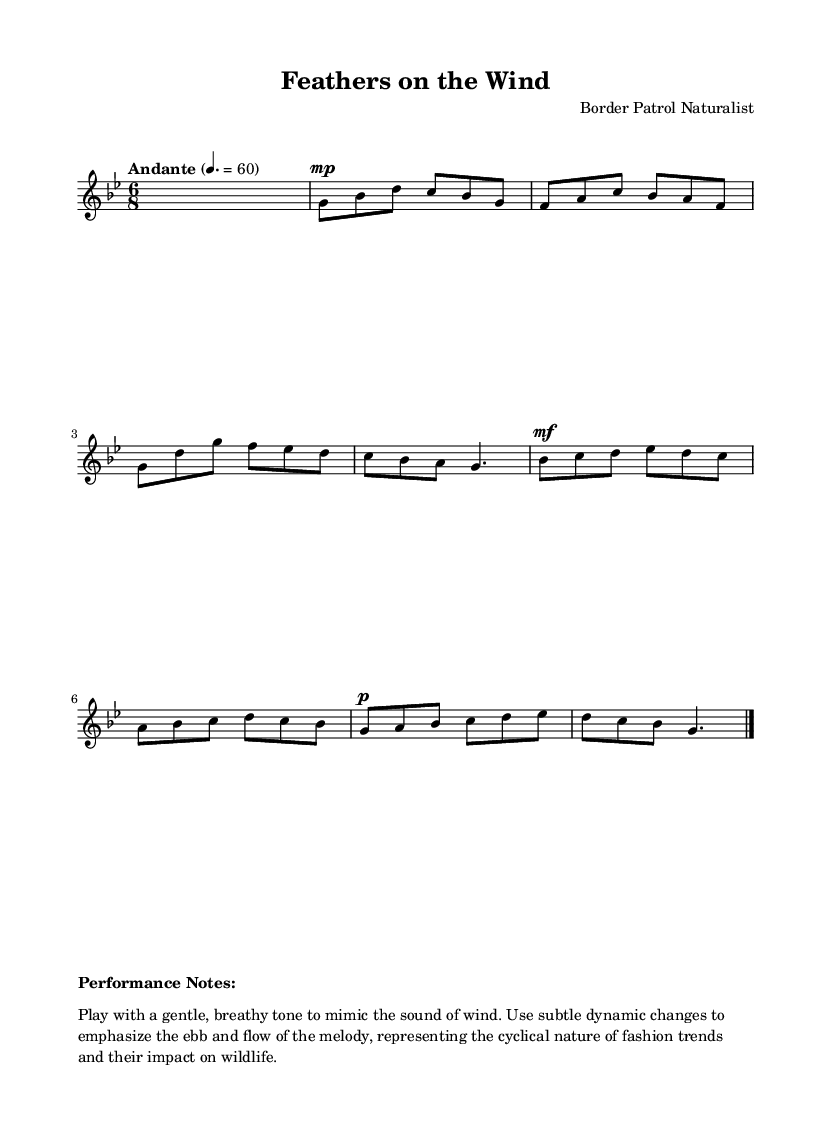What is the title of this music? The title is presented at the top of the sheet music under the header section. It is clearly labeled as "Feathers on the Wind."
Answer: Feathers on the Wind What is the time signature? The time signature can be found at the beginning of the music after the tempo indication. It is written as "6/8."
Answer: 6/8 What is the key signature? The key signature is indicated beside the time signature, showing that the piece is in G minor, which has two flats.
Answer: G minor What is the tempo marking? The tempo marking is indicated in the score, stating "Andante," which suggests a moderately slow pace. It is also accompanied by a metronome marking of quarter note equals 60.
Answer: Andante What dynamics should be used in the performance? The dynamics are indicated at different points in the score. The piece starts with a "mp" marking, meaning "mezzo-piano," and later changes to "mf," meaning "mezzo-forte."
Answer: mp, mf How does the melody reflect the theme of nature in fashion? The performance notes describe that players should use a gentle, breathy tone to mimic the wind and employ dynamic changes to represent the cyclical nature of fashion. This suggests that the music's style evokes connections between natural elements and fashion trends.
Answer: Gentle, breathy tone 